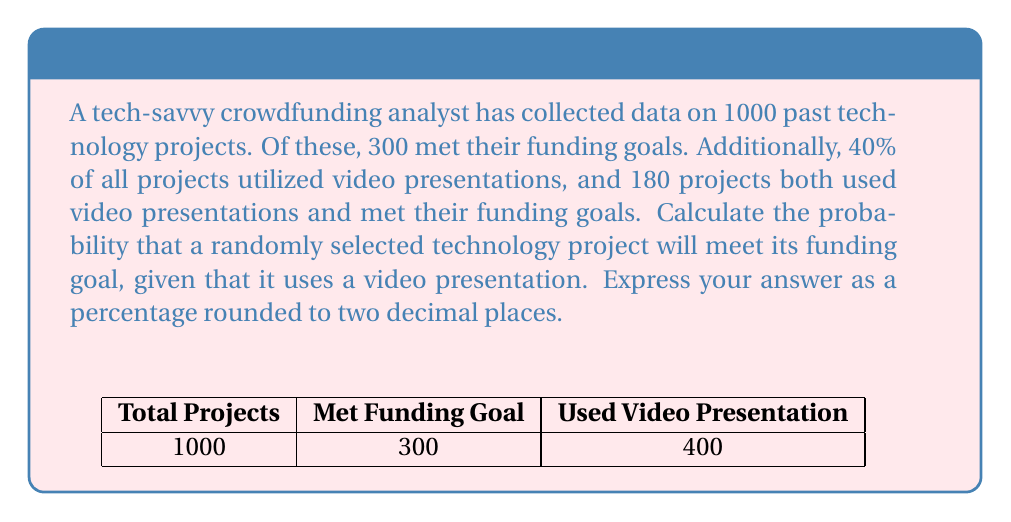Solve this math problem. Let's approach this step-by-step using Bayes' theorem:

1) Define events:
   A: Project meets funding goal
   B: Project uses video presentation

2) Given information:
   P(A) = 300/1000 = 0.3
   P(B) = 40% = 0.4
   P(A ∩ B) = 180/1000 = 0.18

3) We need to find P(A|B), which is given by Bayes' theorem:

   $$P(A|B) = \frac{P(A \cap B)}{P(B)}$$

4) Substituting the values:

   $$P(A|B) = \frac{0.18}{0.4}$$

5) Calculating:

   $$P(A|B) = 0.45$$

6) Converting to percentage and rounding to two decimal places:

   0.45 * 100 = 45.00%

This means that if a technology project uses a video presentation, it has a 45.00% chance of meeting its funding goal based on the historical data provided.
Answer: 45.00% 